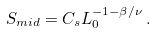Convert formula to latex. <formula><loc_0><loc_0><loc_500><loc_500>S _ { m i d } = C _ { s } L _ { 0 } ^ { - 1 - \beta / \nu } \, .</formula> 